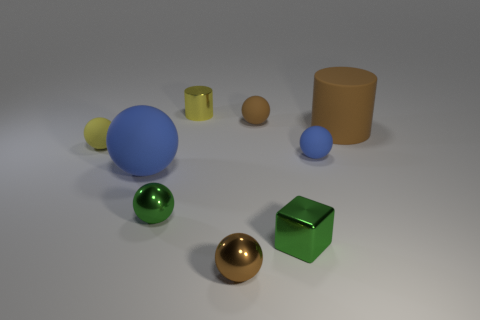What is the color of the big rubber thing that is the same shape as the tiny brown rubber object?
Your response must be concise. Blue. What is the shape of the yellow thing that is behind the large thing on the right side of the large blue ball?
Ensure brevity in your answer.  Cylinder. Is the size of the brown ball behind the yellow rubber object the same as the small shiny cube?
Offer a terse response. Yes. How many other things are the same shape as the big blue thing?
Keep it short and to the point. 5. There is a large rubber cylinder that is in front of the yellow cylinder; does it have the same color as the block?
Your answer should be very brief. No. Is there another big metallic sphere that has the same color as the big ball?
Make the answer very short. No. How many tiny spheres are in front of the small yellow cylinder?
Ensure brevity in your answer.  5. What number of other things are the same size as the yellow shiny thing?
Your answer should be very brief. 6. Do the sphere that is on the right side of the small metal block and the big thing that is to the right of the brown rubber sphere have the same material?
Keep it short and to the point. Yes. What color is the metallic sphere that is the same size as the brown metallic object?
Provide a short and direct response. Green. 